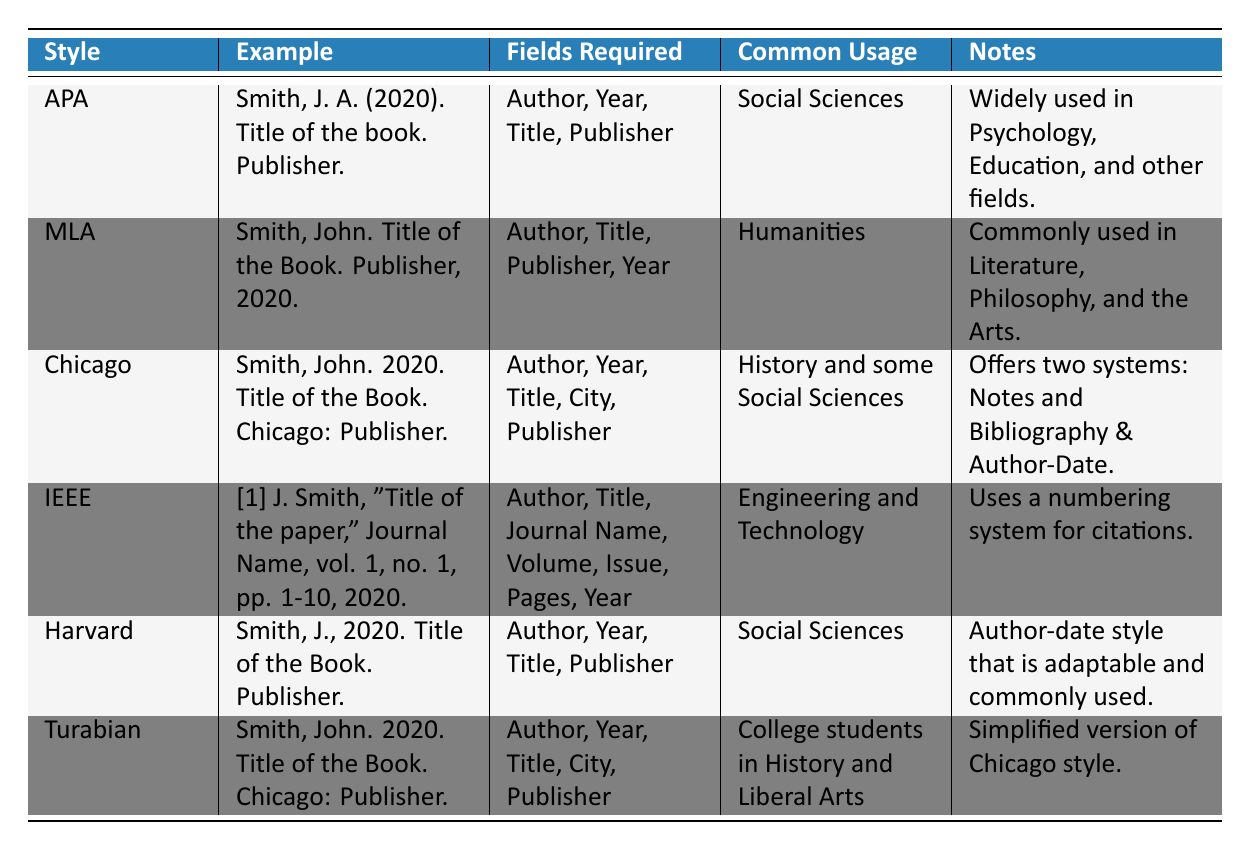What citation style is most commonly used in the Humanities? The table shows that MLA is commonly used in the Humanities.
Answer: MLA How many fields are required for the Chicago citation style? The Chicago citation style requires five fields: Author, Year, Title, City, and Publisher.
Answer: 5 Is the Harvard citation style widely used in Psychology? The table indicates that the Harvard citation style is commonly used in the Social Sciences, but it does not specifically mention Psychology, which is more associated with APA.
Answer: No Which citation style uses a numbering system for citations? The table identifies IEEE as the citation style that employs a numbering system for citations.
Answer: IEEE Which citation style has a simplified version noted for college students? The Turabian citation style is noted as a simplified version of the Chicago style and is used by college students.
Answer: Turabian What is the common usage area for the APA citation style? According to the table, the APA citation style is commonly used in the Social Sciences.
Answer: Social Sciences How many fields are required for the MLA citation style? The MLA citation style requires four fields: Author, Title, Publisher, and Year.
Answer: 4 Does Chicago citation style offer more than one system for citations? The table confirms that the Chicago citation style offers two systems: Notes and Bibliography & Author-Date.
Answer: Yes Which citation style listed requires the author’s first initial rather than full name in the references? The table shows that the APA citation style uses the author's first initial (e.g., J. A.) rather than the full name.
Answer: APA Which citation style's example includes the city of publication? The Chicago and Turabian citation styles' examples both include the city of publication.
Answer: Chicago, Turabian 